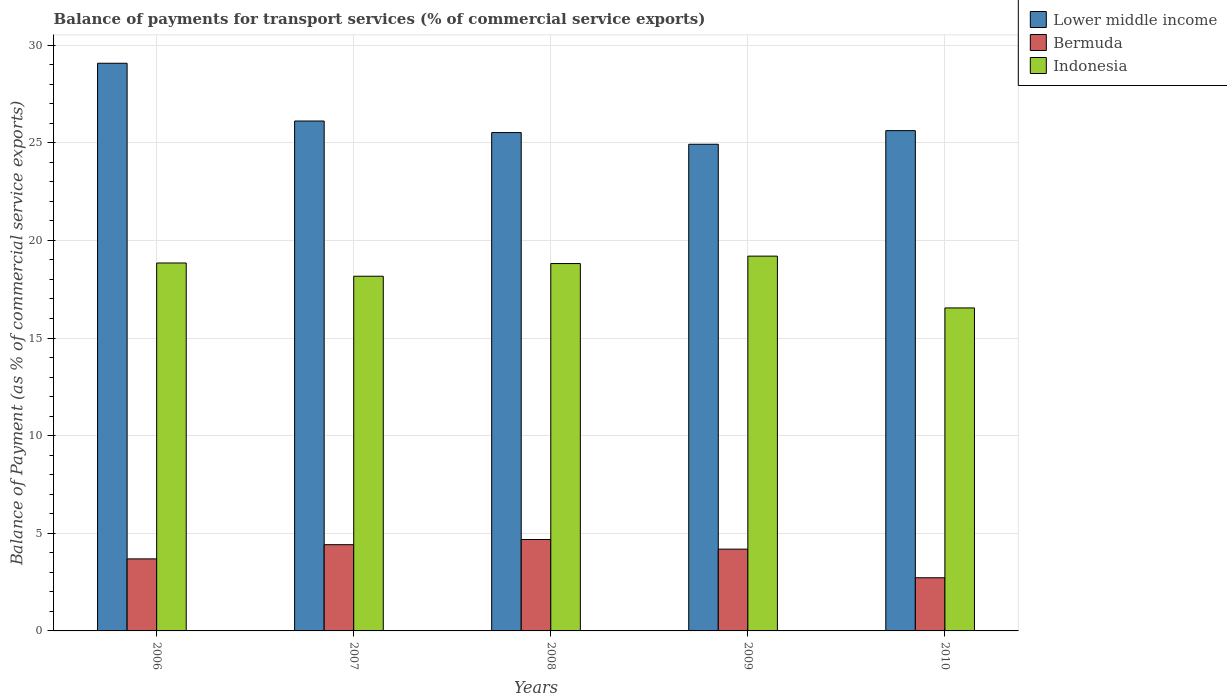How many different coloured bars are there?
Your response must be concise. 3. How many groups of bars are there?
Your answer should be compact. 5. Are the number of bars per tick equal to the number of legend labels?
Your answer should be compact. Yes. How many bars are there on the 2nd tick from the left?
Your answer should be very brief. 3. How many bars are there on the 4th tick from the right?
Your response must be concise. 3. What is the label of the 4th group of bars from the left?
Provide a short and direct response. 2009. What is the balance of payments for transport services in Lower middle income in 2008?
Your answer should be very brief. 25.52. Across all years, what is the maximum balance of payments for transport services in Indonesia?
Your answer should be very brief. 19.19. Across all years, what is the minimum balance of payments for transport services in Lower middle income?
Offer a very short reply. 24.92. In which year was the balance of payments for transport services in Bermuda minimum?
Provide a succinct answer. 2010. What is the total balance of payments for transport services in Bermuda in the graph?
Provide a short and direct response. 19.7. What is the difference between the balance of payments for transport services in Bermuda in 2007 and that in 2009?
Ensure brevity in your answer.  0.23. What is the difference between the balance of payments for transport services in Indonesia in 2007 and the balance of payments for transport services in Lower middle income in 2008?
Your answer should be compact. -7.36. What is the average balance of payments for transport services in Lower middle income per year?
Offer a very short reply. 26.25. In the year 2010, what is the difference between the balance of payments for transport services in Bermuda and balance of payments for transport services in Lower middle income?
Provide a short and direct response. -22.9. In how many years, is the balance of payments for transport services in Lower middle income greater than 1 %?
Provide a succinct answer. 5. What is the ratio of the balance of payments for transport services in Bermuda in 2006 to that in 2009?
Offer a terse response. 0.88. Is the balance of payments for transport services in Indonesia in 2008 less than that in 2009?
Give a very brief answer. Yes. What is the difference between the highest and the second highest balance of payments for transport services in Indonesia?
Provide a short and direct response. 0.35. What is the difference between the highest and the lowest balance of payments for transport services in Lower middle income?
Offer a terse response. 4.15. In how many years, is the balance of payments for transport services in Bermuda greater than the average balance of payments for transport services in Bermuda taken over all years?
Offer a terse response. 3. Is the sum of the balance of payments for transport services in Indonesia in 2008 and 2009 greater than the maximum balance of payments for transport services in Lower middle income across all years?
Your response must be concise. Yes. What does the 2nd bar from the left in 2008 represents?
Give a very brief answer. Bermuda. What does the 2nd bar from the right in 2008 represents?
Your answer should be compact. Bermuda. Is it the case that in every year, the sum of the balance of payments for transport services in Lower middle income and balance of payments for transport services in Indonesia is greater than the balance of payments for transport services in Bermuda?
Offer a very short reply. Yes. How many years are there in the graph?
Give a very brief answer. 5. Are the values on the major ticks of Y-axis written in scientific E-notation?
Make the answer very short. No. Does the graph contain grids?
Make the answer very short. Yes. What is the title of the graph?
Provide a short and direct response. Balance of payments for transport services (% of commercial service exports). Does "Caribbean small states" appear as one of the legend labels in the graph?
Your answer should be compact. No. What is the label or title of the Y-axis?
Provide a succinct answer. Balance of Payment (as % of commercial service exports). What is the Balance of Payment (as % of commercial service exports) of Lower middle income in 2006?
Offer a terse response. 29.07. What is the Balance of Payment (as % of commercial service exports) in Bermuda in 2006?
Your answer should be very brief. 3.69. What is the Balance of Payment (as % of commercial service exports) in Indonesia in 2006?
Ensure brevity in your answer.  18.84. What is the Balance of Payment (as % of commercial service exports) in Lower middle income in 2007?
Give a very brief answer. 26.11. What is the Balance of Payment (as % of commercial service exports) of Bermuda in 2007?
Provide a succinct answer. 4.42. What is the Balance of Payment (as % of commercial service exports) of Indonesia in 2007?
Make the answer very short. 18.16. What is the Balance of Payment (as % of commercial service exports) of Lower middle income in 2008?
Provide a short and direct response. 25.52. What is the Balance of Payment (as % of commercial service exports) of Bermuda in 2008?
Your answer should be very brief. 4.68. What is the Balance of Payment (as % of commercial service exports) of Indonesia in 2008?
Offer a terse response. 18.81. What is the Balance of Payment (as % of commercial service exports) of Lower middle income in 2009?
Provide a short and direct response. 24.92. What is the Balance of Payment (as % of commercial service exports) in Bermuda in 2009?
Your answer should be very brief. 4.19. What is the Balance of Payment (as % of commercial service exports) of Indonesia in 2009?
Ensure brevity in your answer.  19.19. What is the Balance of Payment (as % of commercial service exports) of Lower middle income in 2010?
Keep it short and to the point. 25.62. What is the Balance of Payment (as % of commercial service exports) in Bermuda in 2010?
Ensure brevity in your answer.  2.72. What is the Balance of Payment (as % of commercial service exports) of Indonesia in 2010?
Your response must be concise. 16.54. Across all years, what is the maximum Balance of Payment (as % of commercial service exports) of Lower middle income?
Your response must be concise. 29.07. Across all years, what is the maximum Balance of Payment (as % of commercial service exports) in Bermuda?
Your response must be concise. 4.68. Across all years, what is the maximum Balance of Payment (as % of commercial service exports) of Indonesia?
Make the answer very short. 19.19. Across all years, what is the minimum Balance of Payment (as % of commercial service exports) of Lower middle income?
Keep it short and to the point. 24.92. Across all years, what is the minimum Balance of Payment (as % of commercial service exports) of Bermuda?
Your answer should be compact. 2.72. Across all years, what is the minimum Balance of Payment (as % of commercial service exports) of Indonesia?
Give a very brief answer. 16.54. What is the total Balance of Payment (as % of commercial service exports) of Lower middle income in the graph?
Ensure brevity in your answer.  131.24. What is the total Balance of Payment (as % of commercial service exports) of Bermuda in the graph?
Ensure brevity in your answer.  19.7. What is the total Balance of Payment (as % of commercial service exports) of Indonesia in the graph?
Make the answer very short. 91.55. What is the difference between the Balance of Payment (as % of commercial service exports) in Lower middle income in 2006 and that in 2007?
Your answer should be compact. 2.96. What is the difference between the Balance of Payment (as % of commercial service exports) in Bermuda in 2006 and that in 2007?
Your response must be concise. -0.73. What is the difference between the Balance of Payment (as % of commercial service exports) in Indonesia in 2006 and that in 2007?
Your answer should be compact. 0.68. What is the difference between the Balance of Payment (as % of commercial service exports) of Lower middle income in 2006 and that in 2008?
Your response must be concise. 3.55. What is the difference between the Balance of Payment (as % of commercial service exports) of Bermuda in 2006 and that in 2008?
Keep it short and to the point. -0.99. What is the difference between the Balance of Payment (as % of commercial service exports) in Indonesia in 2006 and that in 2008?
Your answer should be very brief. 0.03. What is the difference between the Balance of Payment (as % of commercial service exports) in Lower middle income in 2006 and that in 2009?
Offer a very short reply. 4.15. What is the difference between the Balance of Payment (as % of commercial service exports) of Bermuda in 2006 and that in 2009?
Offer a terse response. -0.5. What is the difference between the Balance of Payment (as % of commercial service exports) in Indonesia in 2006 and that in 2009?
Provide a short and direct response. -0.35. What is the difference between the Balance of Payment (as % of commercial service exports) of Lower middle income in 2006 and that in 2010?
Keep it short and to the point. 3.45. What is the difference between the Balance of Payment (as % of commercial service exports) of Indonesia in 2006 and that in 2010?
Your answer should be compact. 2.3. What is the difference between the Balance of Payment (as % of commercial service exports) of Lower middle income in 2007 and that in 2008?
Provide a succinct answer. 0.59. What is the difference between the Balance of Payment (as % of commercial service exports) of Bermuda in 2007 and that in 2008?
Provide a short and direct response. -0.27. What is the difference between the Balance of Payment (as % of commercial service exports) of Indonesia in 2007 and that in 2008?
Your response must be concise. -0.65. What is the difference between the Balance of Payment (as % of commercial service exports) of Lower middle income in 2007 and that in 2009?
Provide a short and direct response. 1.19. What is the difference between the Balance of Payment (as % of commercial service exports) of Bermuda in 2007 and that in 2009?
Offer a very short reply. 0.23. What is the difference between the Balance of Payment (as % of commercial service exports) in Indonesia in 2007 and that in 2009?
Your answer should be compact. -1.03. What is the difference between the Balance of Payment (as % of commercial service exports) in Lower middle income in 2007 and that in 2010?
Give a very brief answer. 0.49. What is the difference between the Balance of Payment (as % of commercial service exports) in Bermuda in 2007 and that in 2010?
Your answer should be compact. 1.69. What is the difference between the Balance of Payment (as % of commercial service exports) of Indonesia in 2007 and that in 2010?
Your answer should be compact. 1.62. What is the difference between the Balance of Payment (as % of commercial service exports) of Lower middle income in 2008 and that in 2009?
Your answer should be compact. 0.6. What is the difference between the Balance of Payment (as % of commercial service exports) of Bermuda in 2008 and that in 2009?
Your response must be concise. 0.49. What is the difference between the Balance of Payment (as % of commercial service exports) of Indonesia in 2008 and that in 2009?
Make the answer very short. -0.38. What is the difference between the Balance of Payment (as % of commercial service exports) of Lower middle income in 2008 and that in 2010?
Provide a short and direct response. -0.1. What is the difference between the Balance of Payment (as % of commercial service exports) of Bermuda in 2008 and that in 2010?
Your response must be concise. 1.96. What is the difference between the Balance of Payment (as % of commercial service exports) of Indonesia in 2008 and that in 2010?
Make the answer very short. 2.27. What is the difference between the Balance of Payment (as % of commercial service exports) in Lower middle income in 2009 and that in 2010?
Provide a short and direct response. -0.7. What is the difference between the Balance of Payment (as % of commercial service exports) of Bermuda in 2009 and that in 2010?
Provide a succinct answer. 1.47. What is the difference between the Balance of Payment (as % of commercial service exports) of Indonesia in 2009 and that in 2010?
Provide a short and direct response. 2.65. What is the difference between the Balance of Payment (as % of commercial service exports) in Lower middle income in 2006 and the Balance of Payment (as % of commercial service exports) in Bermuda in 2007?
Provide a short and direct response. 24.65. What is the difference between the Balance of Payment (as % of commercial service exports) in Lower middle income in 2006 and the Balance of Payment (as % of commercial service exports) in Indonesia in 2007?
Provide a short and direct response. 10.91. What is the difference between the Balance of Payment (as % of commercial service exports) in Bermuda in 2006 and the Balance of Payment (as % of commercial service exports) in Indonesia in 2007?
Ensure brevity in your answer.  -14.47. What is the difference between the Balance of Payment (as % of commercial service exports) of Lower middle income in 2006 and the Balance of Payment (as % of commercial service exports) of Bermuda in 2008?
Give a very brief answer. 24.39. What is the difference between the Balance of Payment (as % of commercial service exports) of Lower middle income in 2006 and the Balance of Payment (as % of commercial service exports) of Indonesia in 2008?
Your response must be concise. 10.26. What is the difference between the Balance of Payment (as % of commercial service exports) in Bermuda in 2006 and the Balance of Payment (as % of commercial service exports) in Indonesia in 2008?
Provide a succinct answer. -15.12. What is the difference between the Balance of Payment (as % of commercial service exports) of Lower middle income in 2006 and the Balance of Payment (as % of commercial service exports) of Bermuda in 2009?
Ensure brevity in your answer.  24.88. What is the difference between the Balance of Payment (as % of commercial service exports) in Lower middle income in 2006 and the Balance of Payment (as % of commercial service exports) in Indonesia in 2009?
Provide a short and direct response. 9.88. What is the difference between the Balance of Payment (as % of commercial service exports) of Bermuda in 2006 and the Balance of Payment (as % of commercial service exports) of Indonesia in 2009?
Offer a terse response. -15.5. What is the difference between the Balance of Payment (as % of commercial service exports) of Lower middle income in 2006 and the Balance of Payment (as % of commercial service exports) of Bermuda in 2010?
Provide a succinct answer. 26.35. What is the difference between the Balance of Payment (as % of commercial service exports) of Lower middle income in 2006 and the Balance of Payment (as % of commercial service exports) of Indonesia in 2010?
Your answer should be compact. 12.53. What is the difference between the Balance of Payment (as % of commercial service exports) of Bermuda in 2006 and the Balance of Payment (as % of commercial service exports) of Indonesia in 2010?
Provide a succinct answer. -12.85. What is the difference between the Balance of Payment (as % of commercial service exports) of Lower middle income in 2007 and the Balance of Payment (as % of commercial service exports) of Bermuda in 2008?
Keep it short and to the point. 21.43. What is the difference between the Balance of Payment (as % of commercial service exports) in Lower middle income in 2007 and the Balance of Payment (as % of commercial service exports) in Indonesia in 2008?
Provide a short and direct response. 7.3. What is the difference between the Balance of Payment (as % of commercial service exports) of Bermuda in 2007 and the Balance of Payment (as % of commercial service exports) of Indonesia in 2008?
Provide a short and direct response. -14.4. What is the difference between the Balance of Payment (as % of commercial service exports) of Lower middle income in 2007 and the Balance of Payment (as % of commercial service exports) of Bermuda in 2009?
Ensure brevity in your answer.  21.92. What is the difference between the Balance of Payment (as % of commercial service exports) of Lower middle income in 2007 and the Balance of Payment (as % of commercial service exports) of Indonesia in 2009?
Offer a very short reply. 6.92. What is the difference between the Balance of Payment (as % of commercial service exports) in Bermuda in 2007 and the Balance of Payment (as % of commercial service exports) in Indonesia in 2009?
Your response must be concise. -14.78. What is the difference between the Balance of Payment (as % of commercial service exports) in Lower middle income in 2007 and the Balance of Payment (as % of commercial service exports) in Bermuda in 2010?
Provide a short and direct response. 23.39. What is the difference between the Balance of Payment (as % of commercial service exports) in Lower middle income in 2007 and the Balance of Payment (as % of commercial service exports) in Indonesia in 2010?
Give a very brief answer. 9.57. What is the difference between the Balance of Payment (as % of commercial service exports) in Bermuda in 2007 and the Balance of Payment (as % of commercial service exports) in Indonesia in 2010?
Give a very brief answer. -12.12. What is the difference between the Balance of Payment (as % of commercial service exports) in Lower middle income in 2008 and the Balance of Payment (as % of commercial service exports) in Bermuda in 2009?
Provide a succinct answer. 21.33. What is the difference between the Balance of Payment (as % of commercial service exports) of Lower middle income in 2008 and the Balance of Payment (as % of commercial service exports) of Indonesia in 2009?
Give a very brief answer. 6.33. What is the difference between the Balance of Payment (as % of commercial service exports) of Bermuda in 2008 and the Balance of Payment (as % of commercial service exports) of Indonesia in 2009?
Your response must be concise. -14.51. What is the difference between the Balance of Payment (as % of commercial service exports) of Lower middle income in 2008 and the Balance of Payment (as % of commercial service exports) of Bermuda in 2010?
Ensure brevity in your answer.  22.8. What is the difference between the Balance of Payment (as % of commercial service exports) of Lower middle income in 2008 and the Balance of Payment (as % of commercial service exports) of Indonesia in 2010?
Offer a very short reply. 8.98. What is the difference between the Balance of Payment (as % of commercial service exports) in Bermuda in 2008 and the Balance of Payment (as % of commercial service exports) in Indonesia in 2010?
Offer a very short reply. -11.86. What is the difference between the Balance of Payment (as % of commercial service exports) in Lower middle income in 2009 and the Balance of Payment (as % of commercial service exports) in Bermuda in 2010?
Your response must be concise. 22.2. What is the difference between the Balance of Payment (as % of commercial service exports) of Lower middle income in 2009 and the Balance of Payment (as % of commercial service exports) of Indonesia in 2010?
Provide a succinct answer. 8.38. What is the difference between the Balance of Payment (as % of commercial service exports) in Bermuda in 2009 and the Balance of Payment (as % of commercial service exports) in Indonesia in 2010?
Offer a terse response. -12.35. What is the average Balance of Payment (as % of commercial service exports) of Lower middle income per year?
Offer a very short reply. 26.25. What is the average Balance of Payment (as % of commercial service exports) in Bermuda per year?
Provide a short and direct response. 3.94. What is the average Balance of Payment (as % of commercial service exports) in Indonesia per year?
Provide a short and direct response. 18.31. In the year 2006, what is the difference between the Balance of Payment (as % of commercial service exports) of Lower middle income and Balance of Payment (as % of commercial service exports) of Bermuda?
Your answer should be very brief. 25.38. In the year 2006, what is the difference between the Balance of Payment (as % of commercial service exports) of Lower middle income and Balance of Payment (as % of commercial service exports) of Indonesia?
Give a very brief answer. 10.23. In the year 2006, what is the difference between the Balance of Payment (as % of commercial service exports) of Bermuda and Balance of Payment (as % of commercial service exports) of Indonesia?
Offer a very short reply. -15.15. In the year 2007, what is the difference between the Balance of Payment (as % of commercial service exports) in Lower middle income and Balance of Payment (as % of commercial service exports) in Bermuda?
Offer a terse response. 21.7. In the year 2007, what is the difference between the Balance of Payment (as % of commercial service exports) of Lower middle income and Balance of Payment (as % of commercial service exports) of Indonesia?
Offer a very short reply. 7.95. In the year 2007, what is the difference between the Balance of Payment (as % of commercial service exports) of Bermuda and Balance of Payment (as % of commercial service exports) of Indonesia?
Your answer should be very brief. -13.75. In the year 2008, what is the difference between the Balance of Payment (as % of commercial service exports) in Lower middle income and Balance of Payment (as % of commercial service exports) in Bermuda?
Give a very brief answer. 20.84. In the year 2008, what is the difference between the Balance of Payment (as % of commercial service exports) in Lower middle income and Balance of Payment (as % of commercial service exports) in Indonesia?
Offer a very short reply. 6.71. In the year 2008, what is the difference between the Balance of Payment (as % of commercial service exports) of Bermuda and Balance of Payment (as % of commercial service exports) of Indonesia?
Your response must be concise. -14.13. In the year 2009, what is the difference between the Balance of Payment (as % of commercial service exports) of Lower middle income and Balance of Payment (as % of commercial service exports) of Bermuda?
Keep it short and to the point. 20.73. In the year 2009, what is the difference between the Balance of Payment (as % of commercial service exports) in Lower middle income and Balance of Payment (as % of commercial service exports) in Indonesia?
Your response must be concise. 5.73. In the year 2009, what is the difference between the Balance of Payment (as % of commercial service exports) of Bermuda and Balance of Payment (as % of commercial service exports) of Indonesia?
Provide a succinct answer. -15. In the year 2010, what is the difference between the Balance of Payment (as % of commercial service exports) of Lower middle income and Balance of Payment (as % of commercial service exports) of Bermuda?
Your answer should be very brief. 22.9. In the year 2010, what is the difference between the Balance of Payment (as % of commercial service exports) of Lower middle income and Balance of Payment (as % of commercial service exports) of Indonesia?
Ensure brevity in your answer.  9.08. In the year 2010, what is the difference between the Balance of Payment (as % of commercial service exports) in Bermuda and Balance of Payment (as % of commercial service exports) in Indonesia?
Ensure brevity in your answer.  -13.82. What is the ratio of the Balance of Payment (as % of commercial service exports) of Lower middle income in 2006 to that in 2007?
Provide a short and direct response. 1.11. What is the ratio of the Balance of Payment (as % of commercial service exports) of Bermuda in 2006 to that in 2007?
Make the answer very short. 0.84. What is the ratio of the Balance of Payment (as % of commercial service exports) in Indonesia in 2006 to that in 2007?
Offer a very short reply. 1.04. What is the ratio of the Balance of Payment (as % of commercial service exports) in Lower middle income in 2006 to that in 2008?
Your answer should be very brief. 1.14. What is the ratio of the Balance of Payment (as % of commercial service exports) of Bermuda in 2006 to that in 2008?
Make the answer very short. 0.79. What is the ratio of the Balance of Payment (as % of commercial service exports) of Indonesia in 2006 to that in 2008?
Offer a terse response. 1. What is the ratio of the Balance of Payment (as % of commercial service exports) of Lower middle income in 2006 to that in 2009?
Offer a very short reply. 1.17. What is the ratio of the Balance of Payment (as % of commercial service exports) of Bermuda in 2006 to that in 2009?
Your answer should be very brief. 0.88. What is the ratio of the Balance of Payment (as % of commercial service exports) of Indonesia in 2006 to that in 2009?
Offer a terse response. 0.98. What is the ratio of the Balance of Payment (as % of commercial service exports) in Lower middle income in 2006 to that in 2010?
Provide a short and direct response. 1.13. What is the ratio of the Balance of Payment (as % of commercial service exports) of Bermuda in 2006 to that in 2010?
Offer a very short reply. 1.36. What is the ratio of the Balance of Payment (as % of commercial service exports) of Indonesia in 2006 to that in 2010?
Ensure brevity in your answer.  1.14. What is the ratio of the Balance of Payment (as % of commercial service exports) of Lower middle income in 2007 to that in 2008?
Ensure brevity in your answer.  1.02. What is the ratio of the Balance of Payment (as % of commercial service exports) in Bermuda in 2007 to that in 2008?
Provide a succinct answer. 0.94. What is the ratio of the Balance of Payment (as % of commercial service exports) in Indonesia in 2007 to that in 2008?
Make the answer very short. 0.97. What is the ratio of the Balance of Payment (as % of commercial service exports) of Lower middle income in 2007 to that in 2009?
Your answer should be very brief. 1.05. What is the ratio of the Balance of Payment (as % of commercial service exports) in Bermuda in 2007 to that in 2009?
Ensure brevity in your answer.  1.05. What is the ratio of the Balance of Payment (as % of commercial service exports) of Indonesia in 2007 to that in 2009?
Provide a succinct answer. 0.95. What is the ratio of the Balance of Payment (as % of commercial service exports) of Lower middle income in 2007 to that in 2010?
Make the answer very short. 1.02. What is the ratio of the Balance of Payment (as % of commercial service exports) in Bermuda in 2007 to that in 2010?
Offer a very short reply. 1.62. What is the ratio of the Balance of Payment (as % of commercial service exports) of Indonesia in 2007 to that in 2010?
Offer a very short reply. 1.1. What is the ratio of the Balance of Payment (as % of commercial service exports) in Lower middle income in 2008 to that in 2009?
Keep it short and to the point. 1.02. What is the ratio of the Balance of Payment (as % of commercial service exports) of Bermuda in 2008 to that in 2009?
Offer a very short reply. 1.12. What is the ratio of the Balance of Payment (as % of commercial service exports) in Indonesia in 2008 to that in 2009?
Provide a succinct answer. 0.98. What is the ratio of the Balance of Payment (as % of commercial service exports) of Lower middle income in 2008 to that in 2010?
Your answer should be compact. 1. What is the ratio of the Balance of Payment (as % of commercial service exports) of Bermuda in 2008 to that in 2010?
Your answer should be compact. 1.72. What is the ratio of the Balance of Payment (as % of commercial service exports) in Indonesia in 2008 to that in 2010?
Your answer should be very brief. 1.14. What is the ratio of the Balance of Payment (as % of commercial service exports) of Lower middle income in 2009 to that in 2010?
Make the answer very short. 0.97. What is the ratio of the Balance of Payment (as % of commercial service exports) of Bermuda in 2009 to that in 2010?
Your answer should be compact. 1.54. What is the ratio of the Balance of Payment (as % of commercial service exports) in Indonesia in 2009 to that in 2010?
Provide a short and direct response. 1.16. What is the difference between the highest and the second highest Balance of Payment (as % of commercial service exports) in Lower middle income?
Give a very brief answer. 2.96. What is the difference between the highest and the second highest Balance of Payment (as % of commercial service exports) in Bermuda?
Offer a terse response. 0.27. What is the difference between the highest and the second highest Balance of Payment (as % of commercial service exports) in Indonesia?
Make the answer very short. 0.35. What is the difference between the highest and the lowest Balance of Payment (as % of commercial service exports) in Lower middle income?
Your answer should be very brief. 4.15. What is the difference between the highest and the lowest Balance of Payment (as % of commercial service exports) in Bermuda?
Your answer should be compact. 1.96. What is the difference between the highest and the lowest Balance of Payment (as % of commercial service exports) of Indonesia?
Make the answer very short. 2.65. 